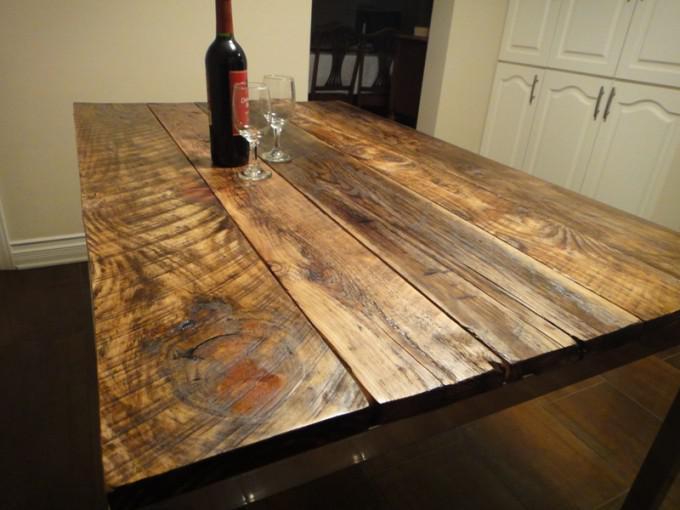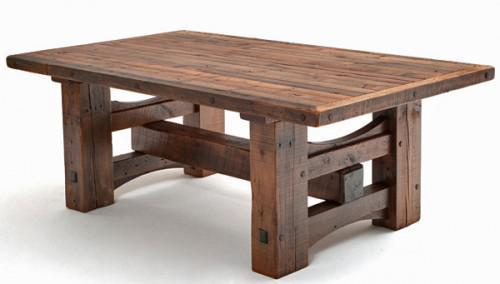The first image is the image on the left, the second image is the image on the right. Considering the images on both sides, is "there are flowers on the table in the image on the right" valid? Answer yes or no. No. The first image is the image on the left, the second image is the image on the right. For the images shown, is this caption "In one image, a table has both chair and bench seating." true? Answer yes or no. No. 